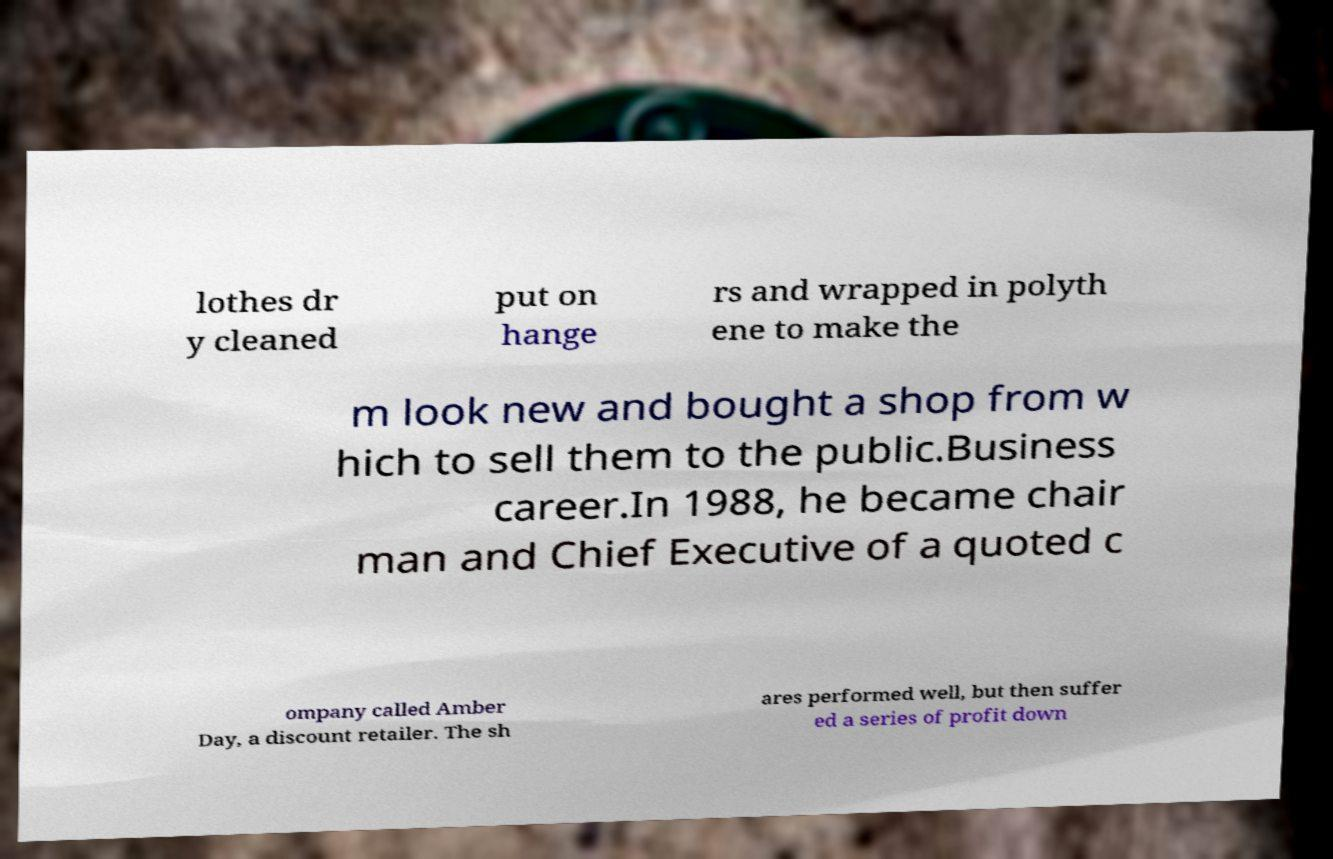Could you extract and type out the text from this image? lothes dr y cleaned put on hange rs and wrapped in polyth ene to make the m look new and bought a shop from w hich to sell them to the public.Business career.In 1988, he became chair man and Chief Executive of a quoted c ompany called Amber Day, a discount retailer. The sh ares performed well, but then suffer ed a series of profit down 